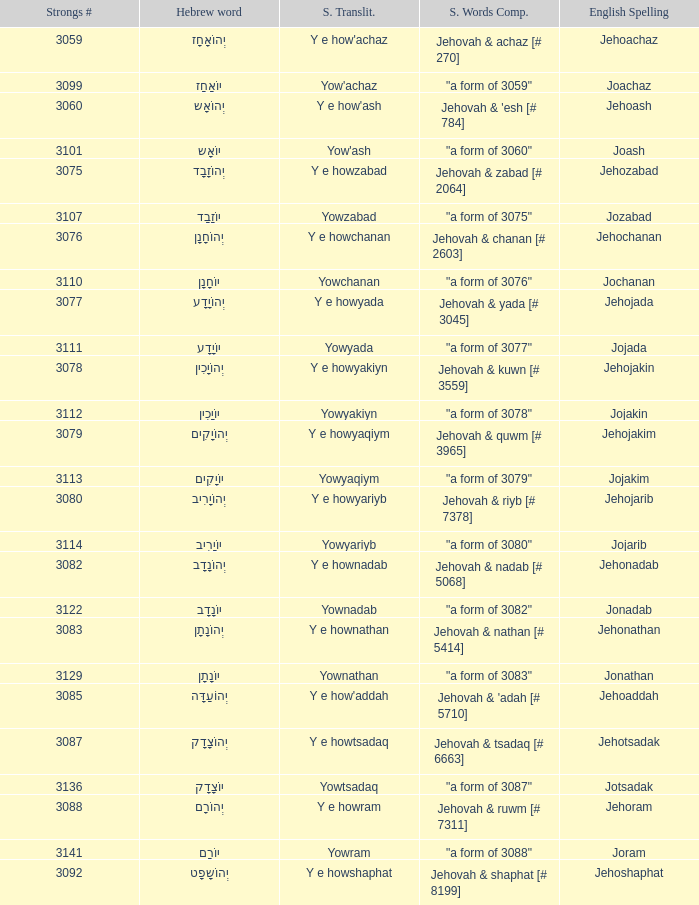What is the strongs words compounded when the english spelling is jonadab? "a form of 3082". 